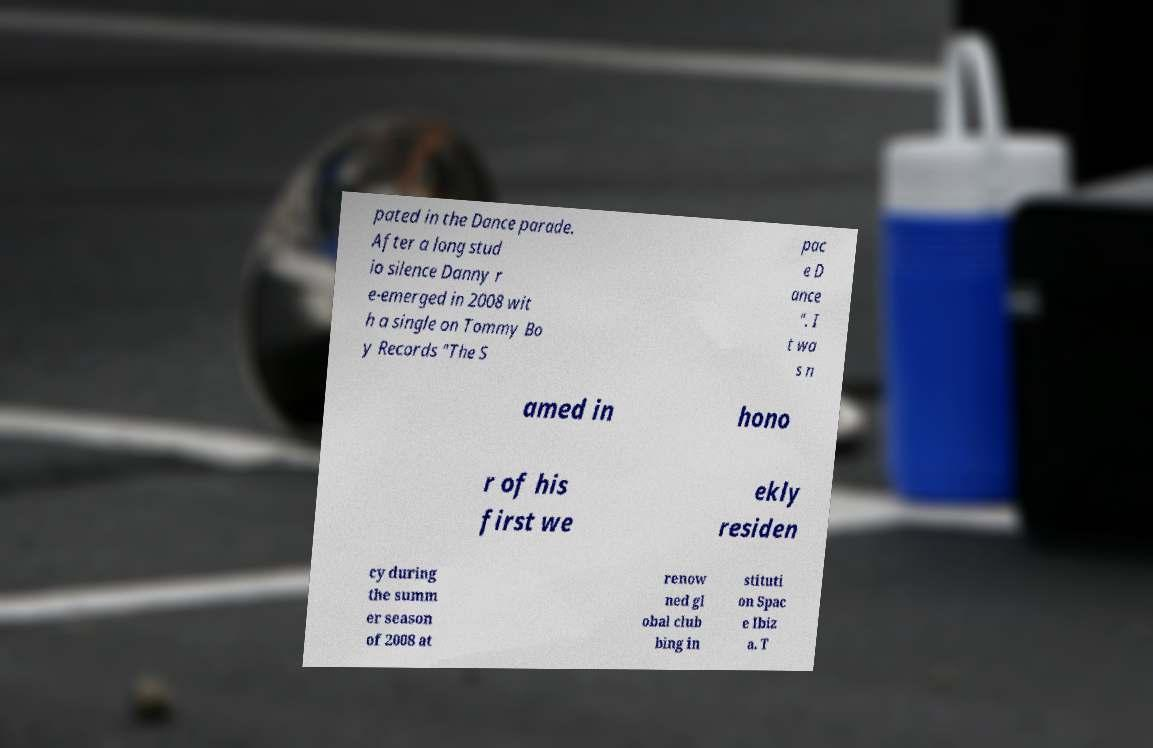Please identify and transcribe the text found in this image. pated in the Dance parade. After a long stud io silence Danny r e-emerged in 2008 wit h a single on Tommy Bo y Records "The S pac e D ance ". I t wa s n amed in hono r of his first we ekly residen cy during the summ er season of 2008 at renow ned gl obal club bing in stituti on Spac e Ibiz a. T 